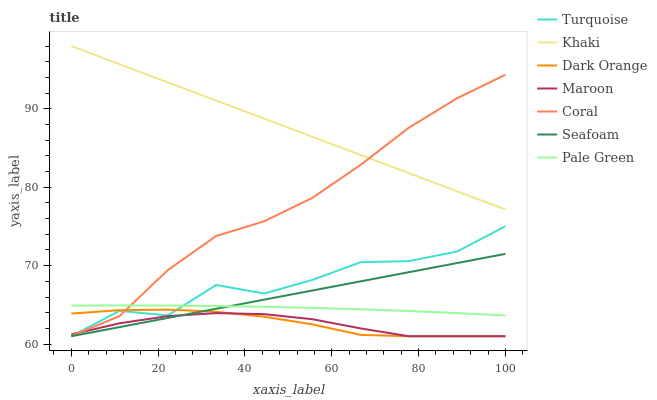Does Maroon have the minimum area under the curve?
Answer yes or no. Yes. Does Khaki have the maximum area under the curve?
Answer yes or no. Yes. Does Turquoise have the minimum area under the curve?
Answer yes or no. No. Does Turquoise have the maximum area under the curve?
Answer yes or no. No. Is Seafoam the smoothest?
Answer yes or no. Yes. Is Turquoise the roughest?
Answer yes or no. Yes. Is Khaki the smoothest?
Answer yes or no. No. Is Khaki the roughest?
Answer yes or no. No. Does Dark Orange have the lowest value?
Answer yes or no. Yes. Does Khaki have the lowest value?
Answer yes or no. No. Does Khaki have the highest value?
Answer yes or no. Yes. Does Turquoise have the highest value?
Answer yes or no. No. Is Dark Orange less than Khaki?
Answer yes or no. Yes. Is Coral greater than Seafoam?
Answer yes or no. Yes. Does Turquoise intersect Pale Green?
Answer yes or no. Yes. Is Turquoise less than Pale Green?
Answer yes or no. No. Is Turquoise greater than Pale Green?
Answer yes or no. No. Does Dark Orange intersect Khaki?
Answer yes or no. No. 